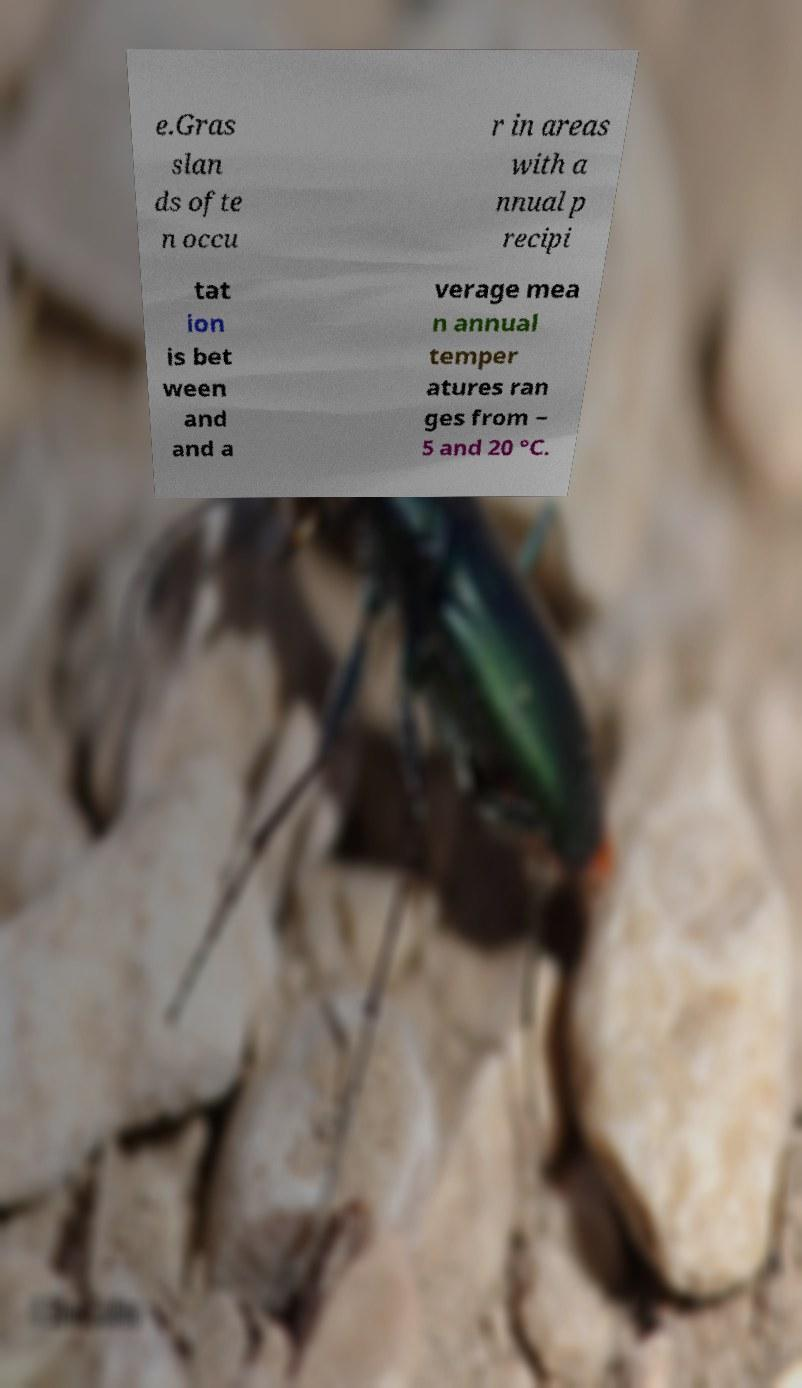What messages or text are displayed in this image? I need them in a readable, typed format. e.Gras slan ds ofte n occu r in areas with a nnual p recipi tat ion is bet ween and and a verage mea n annual temper atures ran ges from − 5 and 20 °C. 